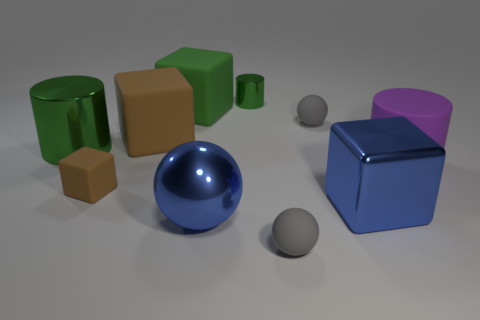Is there another tiny gray object that has the same shape as the small shiny thing?
Your response must be concise. No. What is the color of the metallic ball that is the same size as the blue metal block?
Your answer should be very brief. Blue. There is a metallic cylinder that is in front of the metal cylinder right of the green matte object; what is its color?
Your answer should be very brief. Green. Is the color of the large cylinder left of the blue sphere the same as the rubber cylinder?
Ensure brevity in your answer.  No. What shape is the green shiny object to the right of the metal cylinder on the left side of the brown matte cube that is in front of the large brown block?
Your answer should be very brief. Cylinder. What number of tiny rubber spheres are behind the small sphere that is in front of the big blue block?
Provide a succinct answer. 1. Are the big purple thing and the large brown cube made of the same material?
Give a very brief answer. Yes. How many brown matte cubes are in front of the gray object in front of the blue object on the left side of the tiny green metallic cylinder?
Provide a short and direct response. 0. What is the color of the large cylinder to the right of the small brown matte block?
Ensure brevity in your answer.  Purple. What is the shape of the big blue object right of the cylinder behind the large green rubber object?
Offer a very short reply. Cube. 